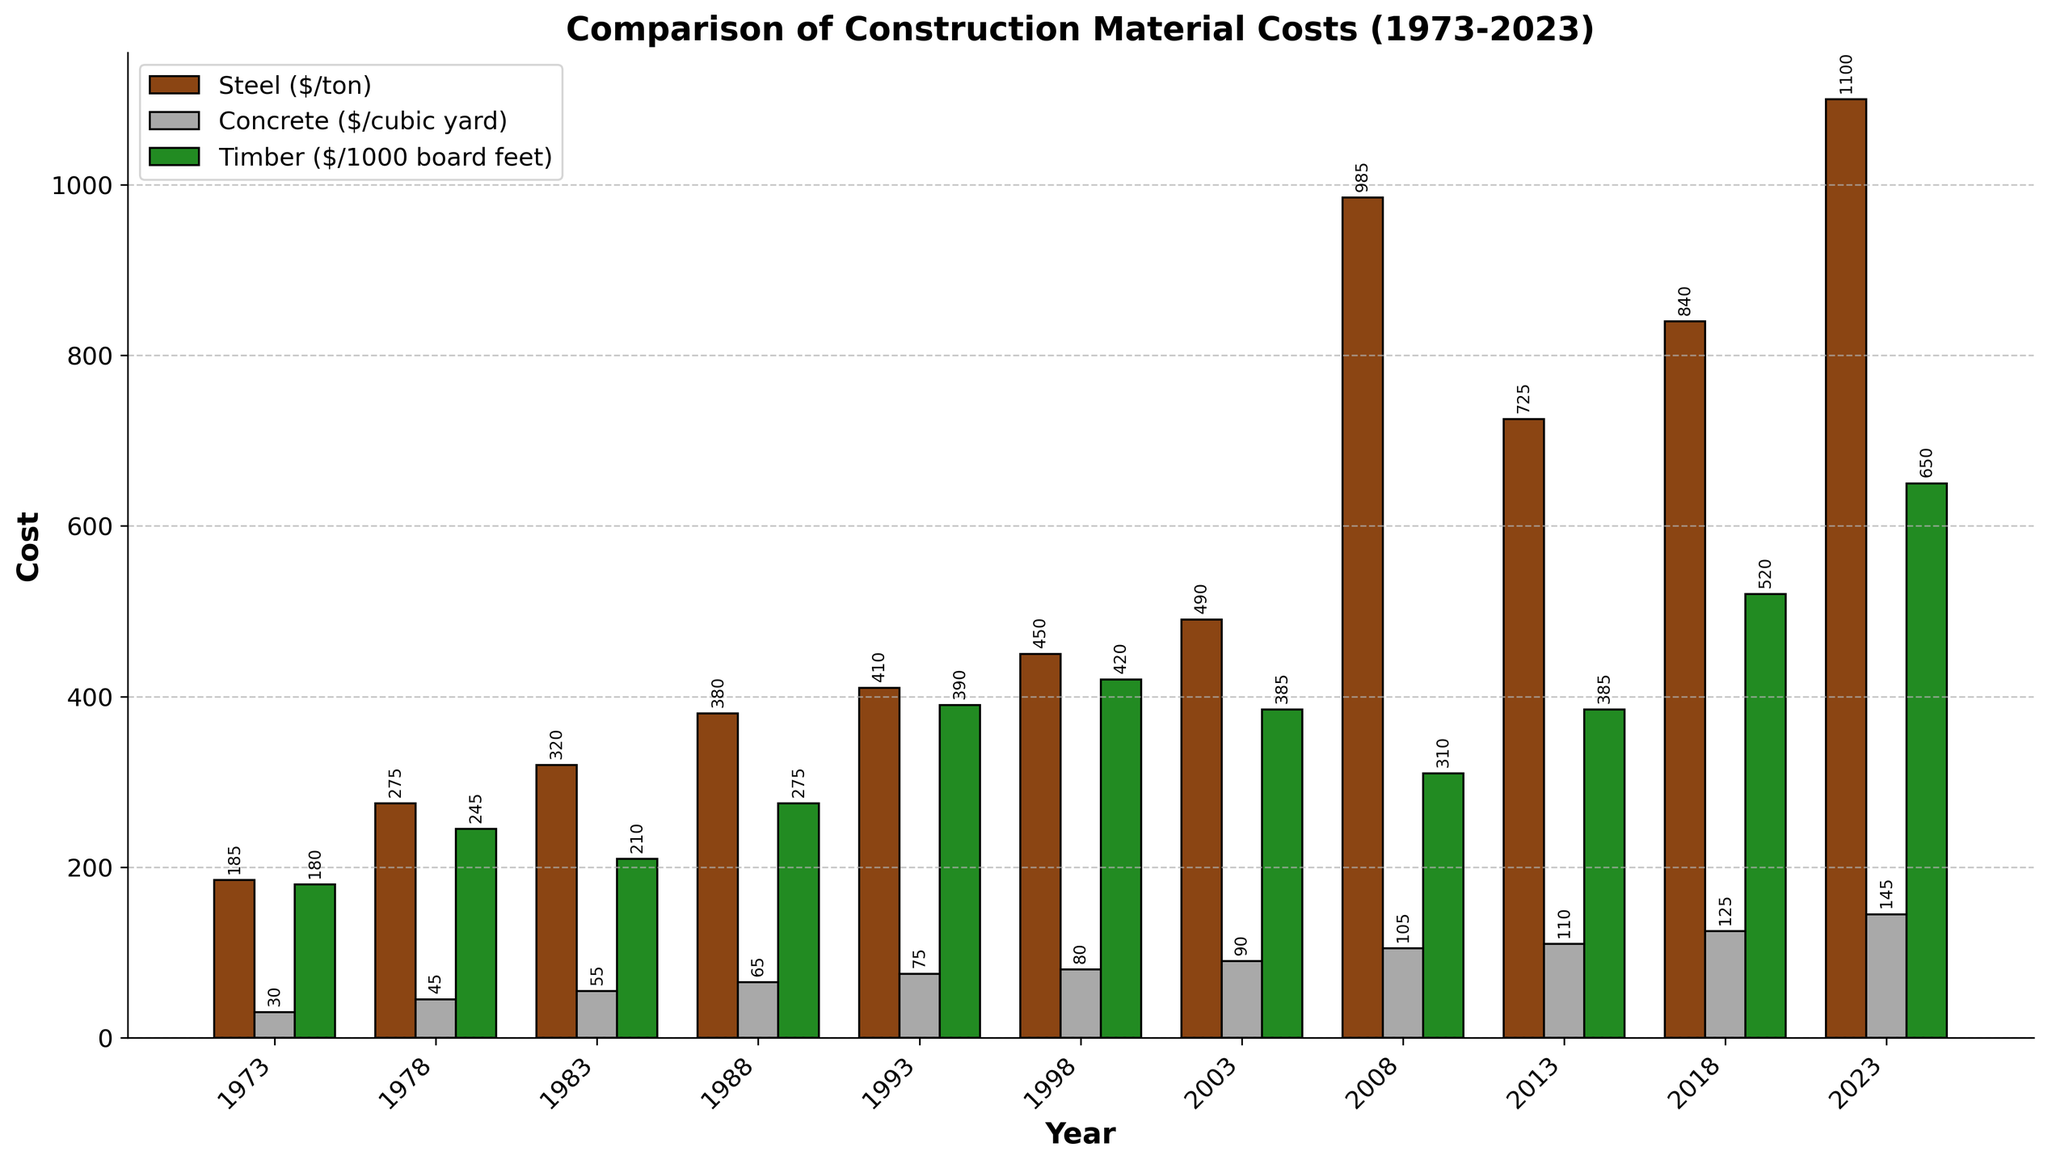What was the cost of steel in 2023? Look at the bar corresponding to the year 2023 and check the height. The bar labeled "Steel ($/ton)" represents the cost of steel. The label next to it shows the value.
Answer: 1100 Which construction material had the highest cost in 1973? Compare the heights of the three bars (Steel, Concrete, Timber) for the year 1973. The tallest bar corresponds to the construction material with the highest cost.
Answer: Steel How much did the cost of timber increase from 2008 to 2023? Find the heights of the Timber bars for 2008 and 2023. Subtract the 2008 value from the 2023 value. The heights are 310 and 650, respectively. So, 650 - 310 = 340.
Answer: 340 Which year saw the highest increase in the cost of steel compared to the previous year? Examine the increments in the heights of the Steel bars between consecutive years. The largest increase occurs between 2003 and 2008.
Answer: 2008 On average, which construction material had the highest cost over the 50 years? Calculate the average cost for each material across all years. Find the sum of the yearly costs for Steel, Concrete, and Timber, then divide each by the number of years (11). Compare the three averages. The calculations confirm Timber has the highest average cost.
Answer: Timber In which year did concrete cost reach $90 per cubic yard? Look for the bar labeled "Concrete ($/cubic yard)" and check the height that equals $90. The corresponding year on the x-axis is the answer.
Answer: 2003 Is there a year where the cost of timber was less than the cost of concrete? Compare the heights of the bars for Timber and Concrete across all years. In 1983, the cost of Timber (210) was less than that of Concrete (55).
Answer: 1983 How did the cost of steel change between 2013 and 2018? Compare the heights of the Steel bars for 2013 and 2018. The cost increased from $725 to $840.
Answer: Increased by 115 What's the difference in the cost of concrete between 1973 and 2023? Compare the heights of the Concrete bars for 1973 and 2023. The values are 30 and 145, respectively. Subtract the 1973 value from the 2023 value: 145 - 30 = 115.
Answer: 115 